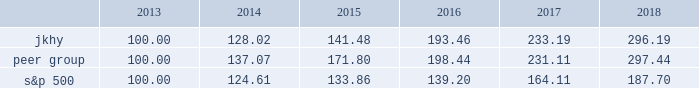14 2018 annual report performance graph the following chart presents a comparison for the five-year period ended june 30 , 2018 , of the market performance of the company 2019s common stock with the s&p 500 index and an index of peer companies selected by the company .
Historic stock price performance is not necessarily indicative of future stock price performance .
Comparison of 5 year cumulative total return among jack henry & associates , inc. , the s&p 500 index , and a peer group the following information depicts a line graph with the following values: .
This comparison assumes $ 100 was invested on june 30 , 2013 , and assumes reinvestments of dividends .
Total returns are calculated according to market capitalization of peer group members at the beginning of each period .
Peer companies selected are in the business of providing specialized computer software , hardware and related services to financial institutions and other businesses .
Companies in the peer group are aci worldwide , inc. ; bottomline technology , inc. ; broadridge financial solutions ; cardtronics , inc. ; convergys corp. ; corelogic , inc. ; euronet worldwide , inc. ; fair isaac corp. ; fidelity national information services , inc. ; fiserv , inc. ; global payments , inc. ; moneygram international , inc. ; ss&c technologies holdings , inc. ; total systems services , inc. ; tyler technologies , inc. ; verifone systems , inc. ; and wex , inc .
Dst systems , inc. , which had previously been part of the peer group , was acquired in 2018 and is no longer a public company .
As a result , dst systems , inc .
Has been removed from the peer group and stock performance graph .
The stock performance graph shall not be deemed 201cfiled 201d for purposes of section 18 of the exchange act , or incorporated by reference into any filing of the company under the securities act of 1933 , as amended , or the exchange act , except as shall be expressly set forth by specific reference in such filing. .
What was the cumulative total return for the peer group over the five years? 
Computations: (297.44 - 100.00)
Answer: 197.44. 